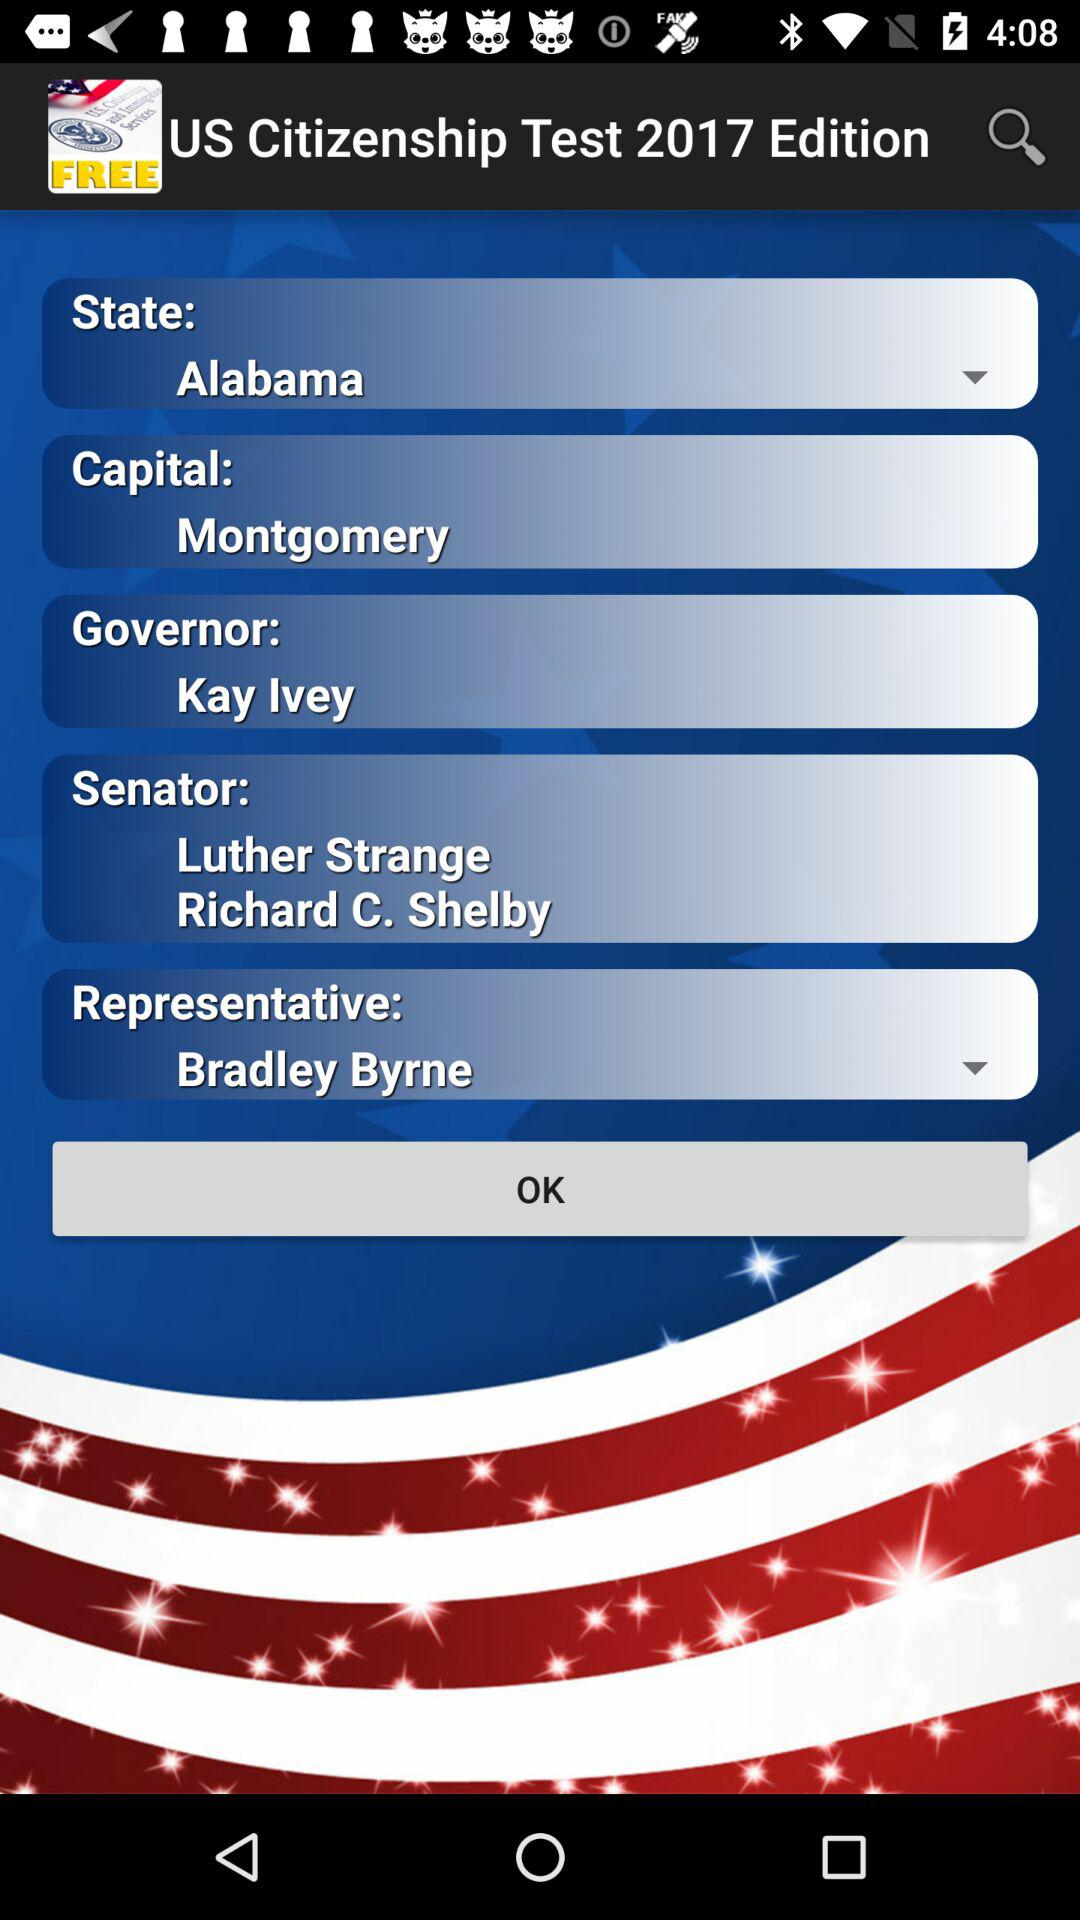Who is the governor? The governor is Kay Ivey. 